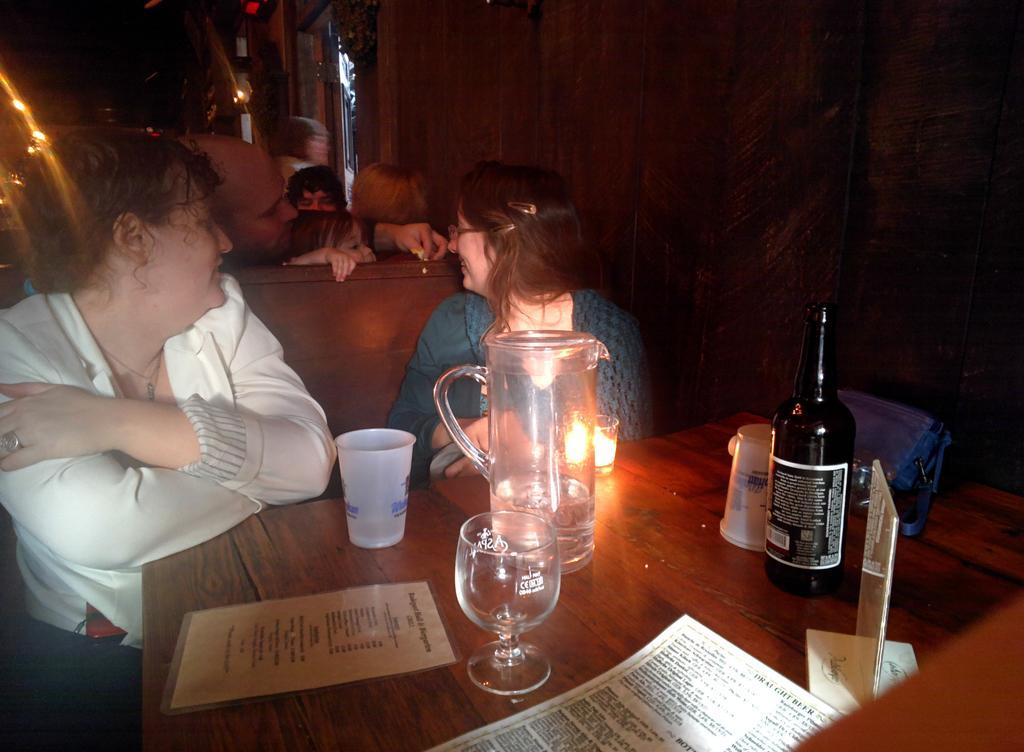How would you summarize this image in a sentence or two? In this image we can see two women sitting on a bench beside a table containing a jar, bottle, some glasses, a bag, a stand and some papers placed on it. On the backside we can see a group of people and some lights. 